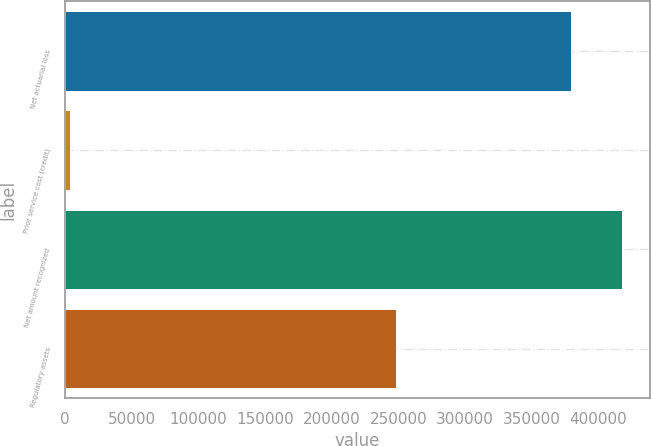Convert chart. <chart><loc_0><loc_0><loc_500><loc_500><bar_chart><fcel>Net actuarial loss<fcel>Prior service cost (credit)<fcel>Net amount recognized<fcel>Regulatory assets<nl><fcel>379743<fcel>3694<fcel>417717<fcel>248641<nl></chart> 